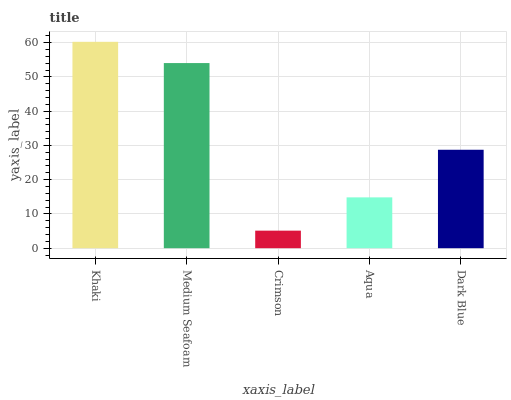Is Crimson the minimum?
Answer yes or no. Yes. Is Khaki the maximum?
Answer yes or no. Yes. Is Medium Seafoam the minimum?
Answer yes or no. No. Is Medium Seafoam the maximum?
Answer yes or no. No. Is Khaki greater than Medium Seafoam?
Answer yes or no. Yes. Is Medium Seafoam less than Khaki?
Answer yes or no. Yes. Is Medium Seafoam greater than Khaki?
Answer yes or no. No. Is Khaki less than Medium Seafoam?
Answer yes or no. No. Is Dark Blue the high median?
Answer yes or no. Yes. Is Dark Blue the low median?
Answer yes or no. Yes. Is Medium Seafoam the high median?
Answer yes or no. No. Is Medium Seafoam the low median?
Answer yes or no. No. 